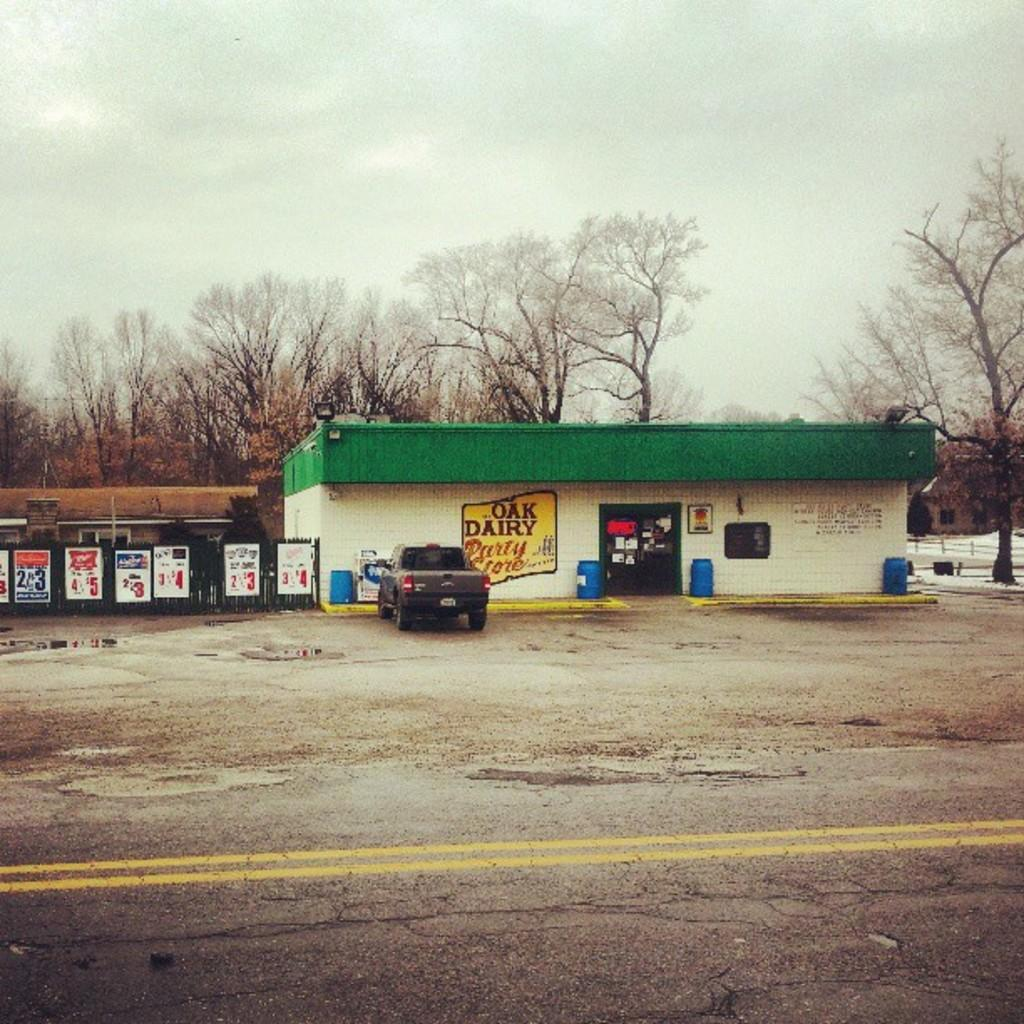What type of structure can be seen in the background of the image? There is a building in the background of the image. What is located in front of the building? There is a truck in front of the building. What is the main feature in the foreground of the image? There is a road in the front of the image. What type of vegetation is visible in the image? There are trees visible in the image. What part of the natural environment is visible in the image? The sky is visible in the image. Can you tell me how many flowers are on the truck in the image? There are no flowers mentioned or visible on the truck in the image. What is the mother doing in the image? There is no mention of a mother or any person's actions in the image. 